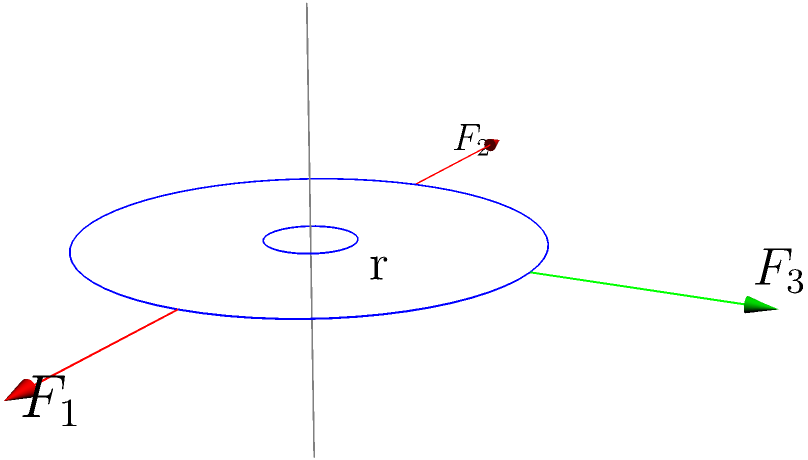A gear system is subjected to three forces as shown in the diagram: $F_1 = 100\text{ N}$ in the positive x-direction, $F_2 = 80\text{ N}$ in the negative x-direction, and $F_3 = 60\text{ N}$ in the positive y-direction. The radius of the gear is 0.5 m. Determine the resulting torque vector on the gear shaft. To determine the torque vector, we'll follow these steps:

1) Recall that torque is given by $\vec{\tau} = \vec{r} \times \vec{F}$, where $\vec{r}$ is the position vector from the axis of rotation to the point of force application.

2) For each force, we need to calculate its contribution to the torque:

   For $F_1$: $\vec{r_1} = (0.5, 0, 0)$ m, $\vec{F_1} = (100, 0, 0)$ N
   $\vec{\tau_1} = (0.5, 0, 0) \times (100, 0, 0) = (0, 0, 0)$ Nm

   For $F_2$: $\vec{r_2} = (-0.5, 0, 0)$ m, $\vec{F_2} = (-80, 0, 0)$ N
   $\vec{\tau_2} = (-0.5, 0, 0) \times (-80, 0, 0) = (0, 0, 0)$ Nm

   For $F_3$: $\vec{r_3} = (0, 0.5, 0)$ m, $\vec{F_3} = (0, 60, 0)$ N
   $\vec{\tau_3} = (0, 0.5, 0) \times (0, 60, 0) = (-30, 0, 0)$ Nm

3) The total torque is the sum of these individual torques:
   $\vec{\tau}_{\text{total}} = \vec{\tau_1} + \vec{\tau_2} + \vec{\tau_3} = (0, 0, 0) + (0, 0, 0) + (-30, 0, 0) = (-30, 0, 0)$ Nm

Therefore, the resulting torque vector is $(-30, 0, 0)$ Nm, or 30 Nm in the negative x-direction.
Answer: $(-30, 0, 0)$ Nm 